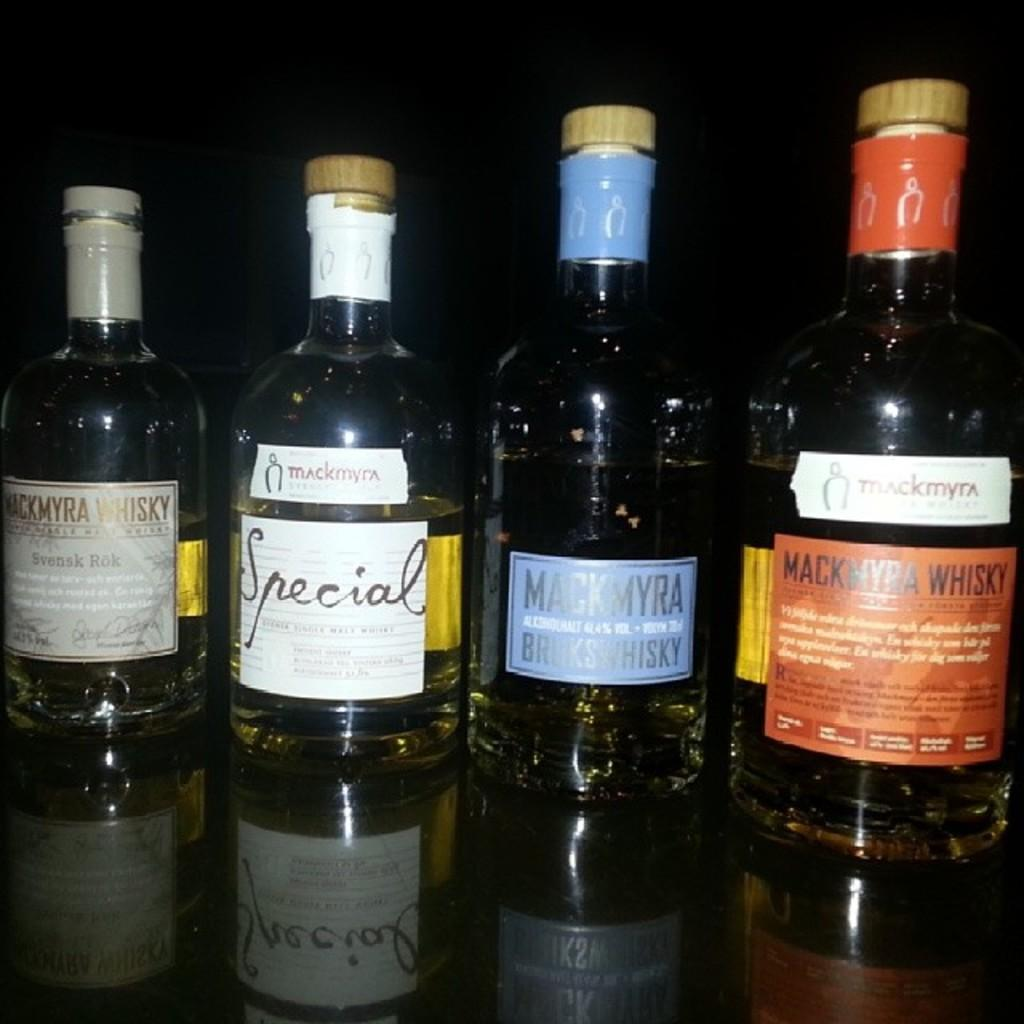<image>
Summarize the visual content of the image. Four bottles of Mackmyra Whisky are on a reflective surface. 